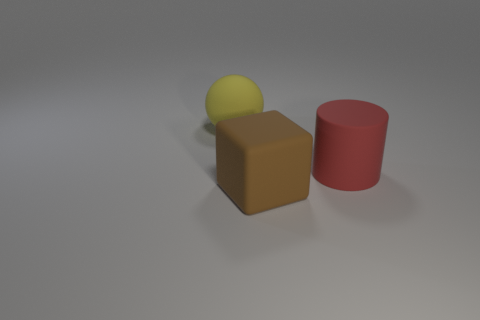What is the arrangement of the objects in relation to each other? The objects are arranged sequentially on what appears to be a flat surface. Starting from the left, we have a yellow sphere, followed by a brown block and finally a red cylinder on the right. They are aligned roughly in the center of the scene, with the sphere slightly touching the block, suggesting a casual placement rather than a precise arrangement. 